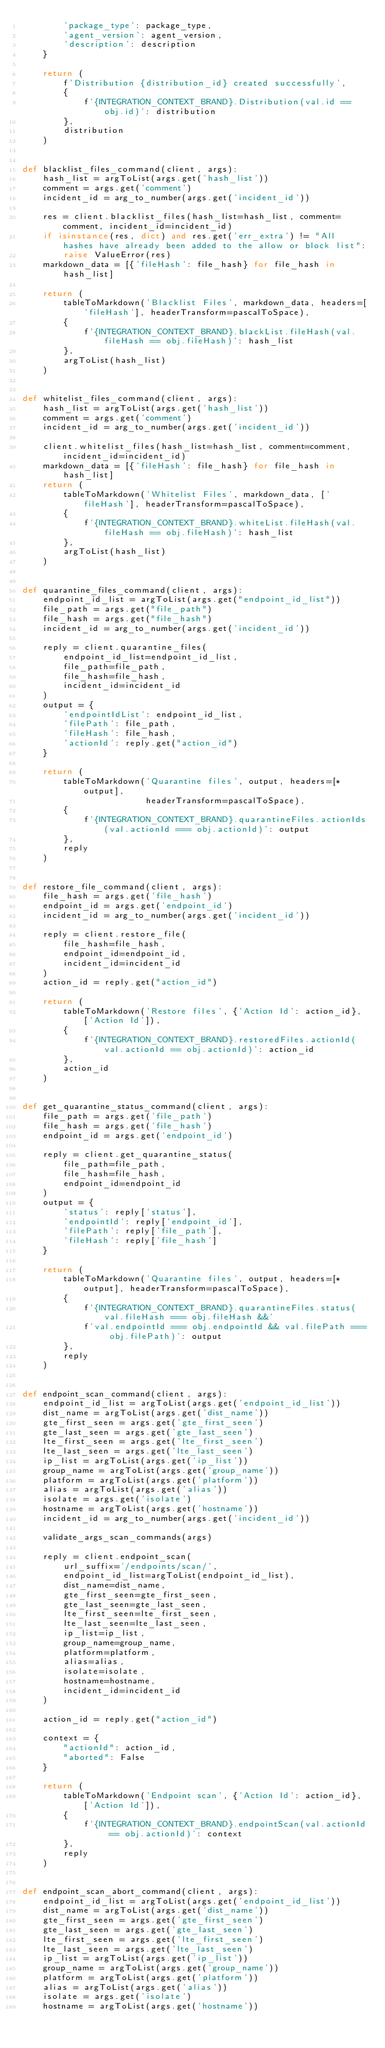<code> <loc_0><loc_0><loc_500><loc_500><_Python_>        'package_type': package_type,
        'agent_version': agent_version,
        'description': description
    }

    return (
        f'Distribution {distribution_id} created successfully',
        {
            f'{INTEGRATION_CONTEXT_BRAND}.Distribution(val.id == obj.id)': distribution
        },
        distribution
    )


def blacklist_files_command(client, args):
    hash_list = argToList(args.get('hash_list'))
    comment = args.get('comment')
    incident_id = arg_to_number(args.get('incident_id'))

    res = client.blacklist_files(hash_list=hash_list, comment=comment, incident_id=incident_id)
    if isinstance(res, dict) and res.get('err_extra') != "All hashes have already been added to the allow or block list":
        raise ValueError(res)
    markdown_data = [{'fileHash': file_hash} for file_hash in hash_list]

    return (
        tableToMarkdown('Blacklist Files', markdown_data, headers=['fileHash'], headerTransform=pascalToSpace),
        {
            f'{INTEGRATION_CONTEXT_BRAND}.blackList.fileHash(val.fileHash == obj.fileHash)': hash_list
        },
        argToList(hash_list)
    )


def whitelist_files_command(client, args):
    hash_list = argToList(args.get('hash_list'))
    comment = args.get('comment')
    incident_id = arg_to_number(args.get('incident_id'))

    client.whitelist_files(hash_list=hash_list, comment=comment, incident_id=incident_id)
    markdown_data = [{'fileHash': file_hash} for file_hash in hash_list]
    return (
        tableToMarkdown('Whitelist Files', markdown_data, ['fileHash'], headerTransform=pascalToSpace),
        {
            f'{INTEGRATION_CONTEXT_BRAND}.whiteList.fileHash(val.fileHash == obj.fileHash)': hash_list
        },
        argToList(hash_list)
    )


def quarantine_files_command(client, args):
    endpoint_id_list = argToList(args.get("endpoint_id_list"))
    file_path = args.get("file_path")
    file_hash = args.get("file_hash")
    incident_id = arg_to_number(args.get('incident_id'))

    reply = client.quarantine_files(
        endpoint_id_list=endpoint_id_list,
        file_path=file_path,
        file_hash=file_hash,
        incident_id=incident_id
    )
    output = {
        'endpointIdList': endpoint_id_list,
        'filePath': file_path,
        'fileHash': file_hash,
        'actionId': reply.get("action_id")
    }

    return (
        tableToMarkdown('Quarantine files', output, headers=[*output],
                        headerTransform=pascalToSpace),
        {
            f'{INTEGRATION_CONTEXT_BRAND}.quarantineFiles.actionIds(val.actionId === obj.actionId)': output
        },
        reply
    )


def restore_file_command(client, args):
    file_hash = args.get('file_hash')
    endpoint_id = args.get('endpoint_id')
    incident_id = arg_to_number(args.get('incident_id'))

    reply = client.restore_file(
        file_hash=file_hash,
        endpoint_id=endpoint_id,
        incident_id=incident_id
    )
    action_id = reply.get("action_id")

    return (
        tableToMarkdown('Restore files', {'Action Id': action_id}, ['Action Id']),
        {
            f'{INTEGRATION_CONTEXT_BRAND}.restoredFiles.actionId(val.actionId == obj.actionId)': action_id
        },
        action_id
    )


def get_quarantine_status_command(client, args):
    file_path = args.get('file_path')
    file_hash = args.get('file_hash')
    endpoint_id = args.get('endpoint_id')

    reply = client.get_quarantine_status(
        file_path=file_path,
        file_hash=file_hash,
        endpoint_id=endpoint_id
    )
    output = {
        'status': reply['status'],
        'endpointId': reply['endpoint_id'],
        'filePath': reply['file_path'],
        'fileHash': reply['file_hash']
    }

    return (
        tableToMarkdown('Quarantine files', output, headers=[*output], headerTransform=pascalToSpace),
        {
            f'{INTEGRATION_CONTEXT_BRAND}.quarantineFiles.status(val.fileHash === obj.fileHash &&'
            f'val.endpointId === obj.endpointId && val.filePath === obj.filePath)': output
        },
        reply
    )


def endpoint_scan_command(client, args):
    endpoint_id_list = argToList(args.get('endpoint_id_list'))
    dist_name = argToList(args.get('dist_name'))
    gte_first_seen = args.get('gte_first_seen')
    gte_last_seen = args.get('gte_last_seen')
    lte_first_seen = args.get('lte_first_seen')
    lte_last_seen = args.get('lte_last_seen')
    ip_list = argToList(args.get('ip_list'))
    group_name = argToList(args.get('group_name'))
    platform = argToList(args.get('platform'))
    alias = argToList(args.get('alias'))
    isolate = args.get('isolate')
    hostname = argToList(args.get('hostname'))
    incident_id = arg_to_number(args.get('incident_id'))

    validate_args_scan_commands(args)

    reply = client.endpoint_scan(
        url_suffix='/endpoints/scan/',
        endpoint_id_list=argToList(endpoint_id_list),
        dist_name=dist_name,
        gte_first_seen=gte_first_seen,
        gte_last_seen=gte_last_seen,
        lte_first_seen=lte_first_seen,
        lte_last_seen=lte_last_seen,
        ip_list=ip_list,
        group_name=group_name,
        platform=platform,
        alias=alias,
        isolate=isolate,
        hostname=hostname,
        incident_id=incident_id
    )

    action_id = reply.get("action_id")

    context = {
        "actionId": action_id,
        "aborted": False
    }

    return (
        tableToMarkdown('Endpoint scan', {'Action Id': action_id}, ['Action Id']),
        {
            f'{INTEGRATION_CONTEXT_BRAND}.endpointScan(val.actionId == obj.actionId)': context
        },
        reply
    )


def endpoint_scan_abort_command(client, args):
    endpoint_id_list = argToList(args.get('endpoint_id_list'))
    dist_name = argToList(args.get('dist_name'))
    gte_first_seen = args.get('gte_first_seen')
    gte_last_seen = args.get('gte_last_seen')
    lte_first_seen = args.get('lte_first_seen')
    lte_last_seen = args.get('lte_last_seen')
    ip_list = argToList(args.get('ip_list'))
    group_name = argToList(args.get('group_name'))
    platform = argToList(args.get('platform'))
    alias = argToList(args.get('alias'))
    isolate = args.get('isolate')
    hostname = argToList(args.get('hostname'))</code> 